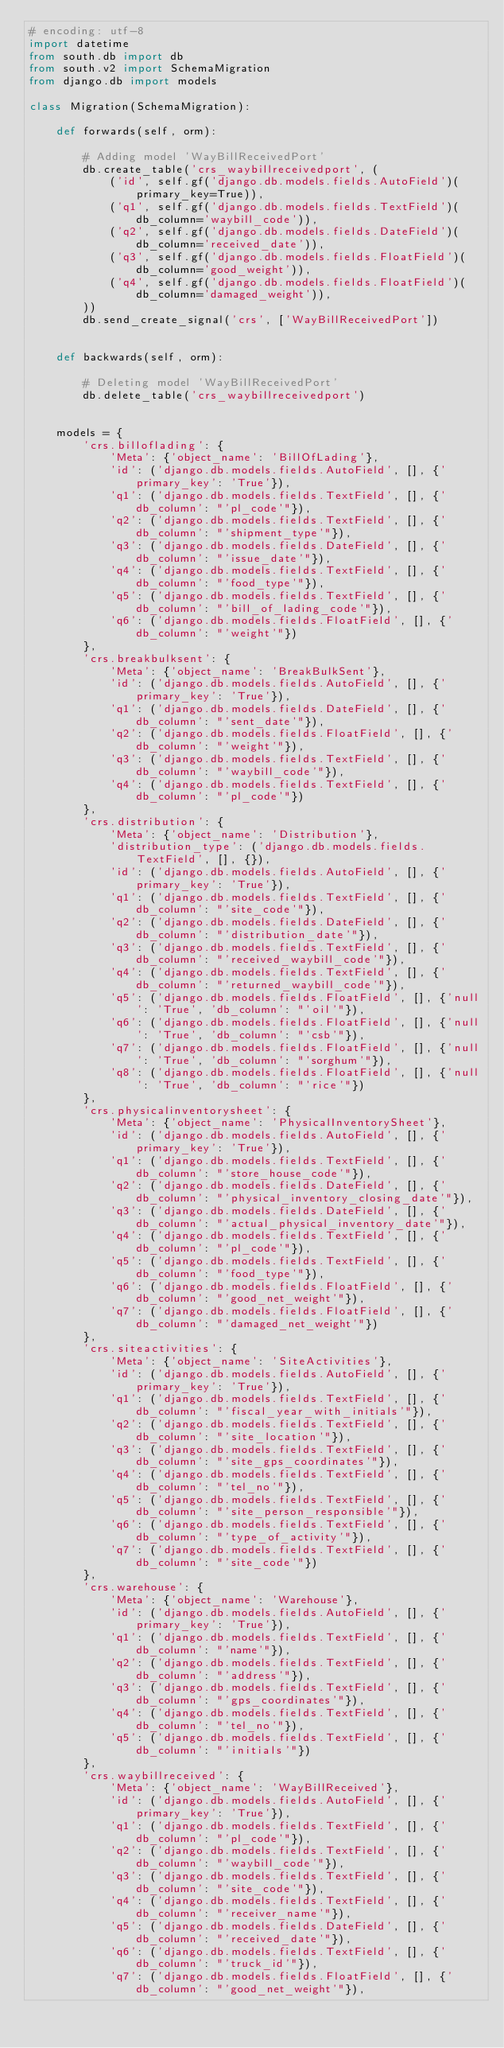<code> <loc_0><loc_0><loc_500><loc_500><_Python_># encoding: utf-8
import datetime
from south.db import db
from south.v2 import SchemaMigration
from django.db import models

class Migration(SchemaMigration):

    def forwards(self, orm):
        
        # Adding model 'WayBillReceivedPort'
        db.create_table('crs_waybillreceivedport', (
            ('id', self.gf('django.db.models.fields.AutoField')(primary_key=True)),
            ('q1', self.gf('django.db.models.fields.TextField')(db_column='waybill_code')),
            ('q2', self.gf('django.db.models.fields.DateField')(db_column='received_date')),
            ('q3', self.gf('django.db.models.fields.FloatField')(db_column='good_weight')),
            ('q4', self.gf('django.db.models.fields.FloatField')(db_column='damaged_weight')),
        ))
        db.send_create_signal('crs', ['WayBillReceivedPort'])


    def backwards(self, orm):
        
        # Deleting model 'WayBillReceivedPort'
        db.delete_table('crs_waybillreceivedport')


    models = {
        'crs.billoflading': {
            'Meta': {'object_name': 'BillOfLading'},
            'id': ('django.db.models.fields.AutoField', [], {'primary_key': 'True'}),
            'q1': ('django.db.models.fields.TextField', [], {'db_column': "'pl_code'"}),
            'q2': ('django.db.models.fields.TextField', [], {'db_column': "'shipment_type'"}),
            'q3': ('django.db.models.fields.DateField', [], {'db_column': "'issue_date'"}),
            'q4': ('django.db.models.fields.TextField', [], {'db_column': "'food_type'"}),
            'q5': ('django.db.models.fields.TextField', [], {'db_column': "'bill_of_lading_code'"}),
            'q6': ('django.db.models.fields.FloatField', [], {'db_column': "'weight'"})
        },
        'crs.breakbulksent': {
            'Meta': {'object_name': 'BreakBulkSent'},
            'id': ('django.db.models.fields.AutoField', [], {'primary_key': 'True'}),
            'q1': ('django.db.models.fields.DateField', [], {'db_column': "'sent_date'"}),
            'q2': ('django.db.models.fields.FloatField', [], {'db_column': "'weight'"}),
            'q3': ('django.db.models.fields.TextField', [], {'db_column': "'waybill_code'"}),
            'q4': ('django.db.models.fields.TextField', [], {'db_column': "'pl_code'"})
        },
        'crs.distribution': {
            'Meta': {'object_name': 'Distribution'},
            'distribution_type': ('django.db.models.fields.TextField', [], {}),
            'id': ('django.db.models.fields.AutoField', [], {'primary_key': 'True'}),
            'q1': ('django.db.models.fields.TextField', [], {'db_column': "'site_code'"}),
            'q2': ('django.db.models.fields.DateField', [], {'db_column': "'distribution_date'"}),
            'q3': ('django.db.models.fields.TextField', [], {'db_column': "'received_waybill_code'"}),
            'q4': ('django.db.models.fields.TextField', [], {'db_column': "'returned_waybill_code'"}),
            'q5': ('django.db.models.fields.FloatField', [], {'null': 'True', 'db_column': "'oil'"}),
            'q6': ('django.db.models.fields.FloatField', [], {'null': 'True', 'db_column': "'csb'"}),
            'q7': ('django.db.models.fields.FloatField', [], {'null': 'True', 'db_column': "'sorghum'"}),
            'q8': ('django.db.models.fields.FloatField', [], {'null': 'True', 'db_column': "'rice'"})
        },
        'crs.physicalinventorysheet': {
            'Meta': {'object_name': 'PhysicalInventorySheet'},
            'id': ('django.db.models.fields.AutoField', [], {'primary_key': 'True'}),
            'q1': ('django.db.models.fields.TextField', [], {'db_column': "'store_house_code'"}),
            'q2': ('django.db.models.fields.DateField', [], {'db_column': "'physical_inventory_closing_date'"}),
            'q3': ('django.db.models.fields.DateField', [], {'db_column': "'actual_physical_inventory_date'"}),
            'q4': ('django.db.models.fields.TextField', [], {'db_column': "'pl_code'"}),
            'q5': ('django.db.models.fields.TextField', [], {'db_column': "'food_type'"}),
            'q6': ('django.db.models.fields.FloatField', [], {'db_column': "'good_net_weight'"}),
            'q7': ('django.db.models.fields.FloatField', [], {'db_column': "'damaged_net_weight'"})
        },
        'crs.siteactivities': {
            'Meta': {'object_name': 'SiteActivities'},
            'id': ('django.db.models.fields.AutoField', [], {'primary_key': 'True'}),
            'q1': ('django.db.models.fields.TextField', [], {'db_column': "'fiscal_year_with_initials'"}),
            'q2': ('django.db.models.fields.TextField', [], {'db_column': "'site_location'"}),
            'q3': ('django.db.models.fields.TextField', [], {'db_column': "'site_gps_coordinates'"}),
            'q4': ('django.db.models.fields.TextField', [], {'db_column': "'tel_no'"}),
            'q5': ('django.db.models.fields.TextField', [], {'db_column': "'site_person_responsible'"}),
            'q6': ('django.db.models.fields.TextField', [], {'db_column': "'type_of_activity'"}),
            'q7': ('django.db.models.fields.TextField', [], {'db_column': "'site_code'"})
        },
        'crs.warehouse': {
            'Meta': {'object_name': 'Warehouse'},
            'id': ('django.db.models.fields.AutoField', [], {'primary_key': 'True'}),
            'q1': ('django.db.models.fields.TextField', [], {'db_column': "'name'"}),
            'q2': ('django.db.models.fields.TextField', [], {'db_column': "'address'"}),
            'q3': ('django.db.models.fields.TextField', [], {'db_column': "'gps_coordinates'"}),
            'q4': ('django.db.models.fields.TextField', [], {'db_column': "'tel_no'"}),
            'q5': ('django.db.models.fields.TextField', [], {'db_column': "'initials'"})
        },
        'crs.waybillreceived': {
            'Meta': {'object_name': 'WayBillReceived'},
            'id': ('django.db.models.fields.AutoField', [], {'primary_key': 'True'}),
            'q1': ('django.db.models.fields.TextField', [], {'db_column': "'pl_code'"}),
            'q2': ('django.db.models.fields.TextField', [], {'db_column': "'waybill_code'"}),
            'q3': ('django.db.models.fields.TextField', [], {'db_column': "'site_code'"}),
            'q4': ('django.db.models.fields.TextField', [], {'db_column': "'receiver_name'"}),
            'q5': ('django.db.models.fields.DateField', [], {'db_column': "'received_date'"}),
            'q6': ('django.db.models.fields.TextField', [], {'db_column': "'truck_id'"}),
            'q7': ('django.db.models.fields.FloatField', [], {'db_column': "'good_net_weight'"}),</code> 